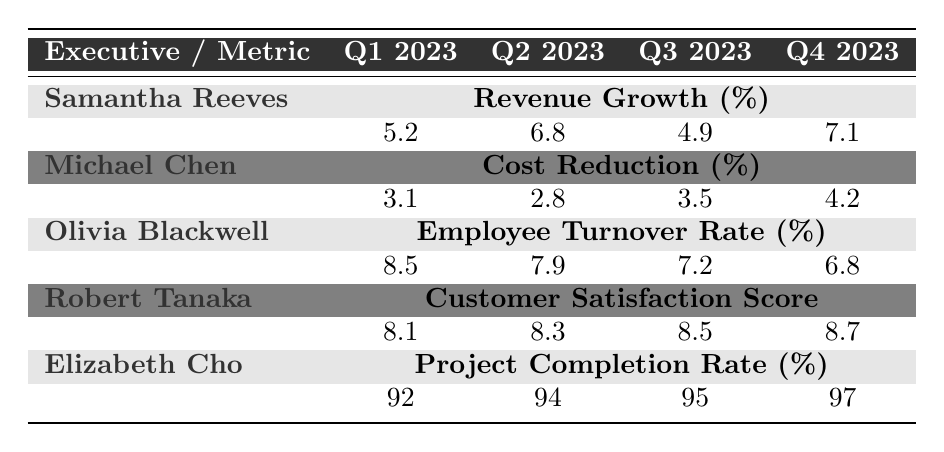What was the revenue growth percentage for Samantha Reeves in Q2 2023? Looking at the table, Samantha Reeves has a revenue growth percentage of 6.8% in Q2 2023.
Answer: 6.8% Which executive had the highest customer satisfaction score in Q4 2023? Robert Tanaka had the highest customer satisfaction score of 8.7 in Q4 2023 according to the table.
Answer: Robert Tanaka What is the average employee turnover rate for Olivia Blackwell over the four quarters? To find the average, sum the employee turnover rates for the four quarters: (8.5 + 7.9 + 7.2 + 6.8) = 30.4. Then divide by 4, giving 30.4 / 4 = 7.6.
Answer: 7.6 Did Michael Chen show an improvement in cost reduction from Q1 2023 to Q4 2023? In Q1 2023, Michael Chen had a cost reduction percentage of 3.1% and increased to 4.2% in Q4 2023, indicating an improvement.
Answer: Yes What is the difference in project completion rate from Q1 2023 to Q4 2023 for Elizabeth Cho? For Elizabeth Cho, the project completion rate in Q1 2023 was 92% and in Q4 2023 it was 97%. The difference is 97 - 92 = 5%.
Answer: 5% Who achieved the highest revenue growth in Q4 2023? In Q4 2023, Samantha Reeves had the highest revenue growth percentage of 7.1%.
Answer: Samantha Reeves Which executive improved their employee turnover rate the most from Q1 2023 to Q4 2023? Olivia Blackwell's employee turnover rate decreased from 8.5% in Q1 2023 to 6.8% in Q4 2023, a decrease of 1.7%. This is the most improvement noted.
Answer: Olivia Blackwell What is the total cost reduction percentage achieved by Michael Chen over the four quarters? Adding Michael Chen's percentages: 3.1 + 2.8 + 3.5 + 4.2 = 13.6%.
Answer: 13.6% In which quarter did Elizabeth Cho achieve the highest project completion rate? Elizabeth Cho achieved the highest project completion rate of 97% in Q4 2023.
Answer: Q4 2023 Is it true that Robert Tanaka's customer satisfaction score was below 8.0 in any quarter? Robert Tanaka's scores were 8.1, 8.3, 8.5, and 8.7 across the four quarters, all above 8.0, so the statement is false.
Answer: No 